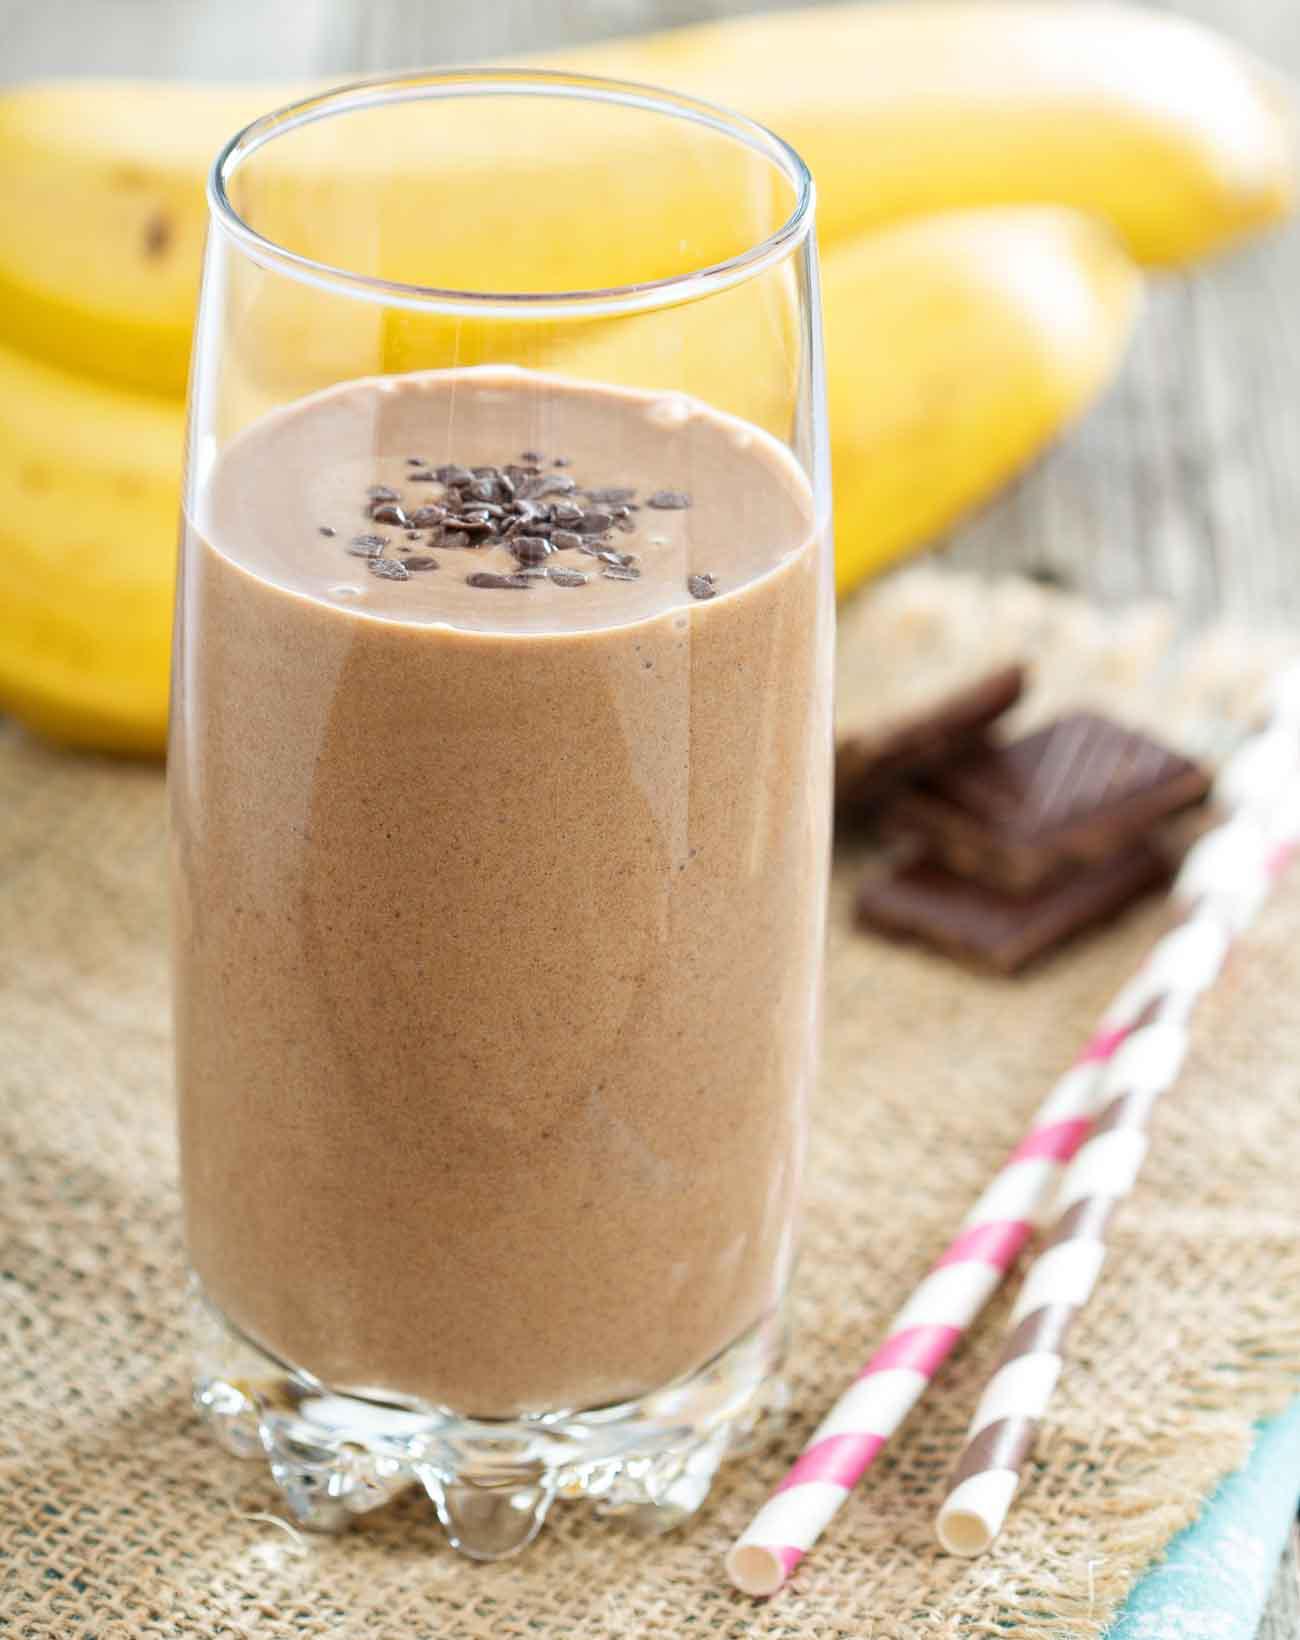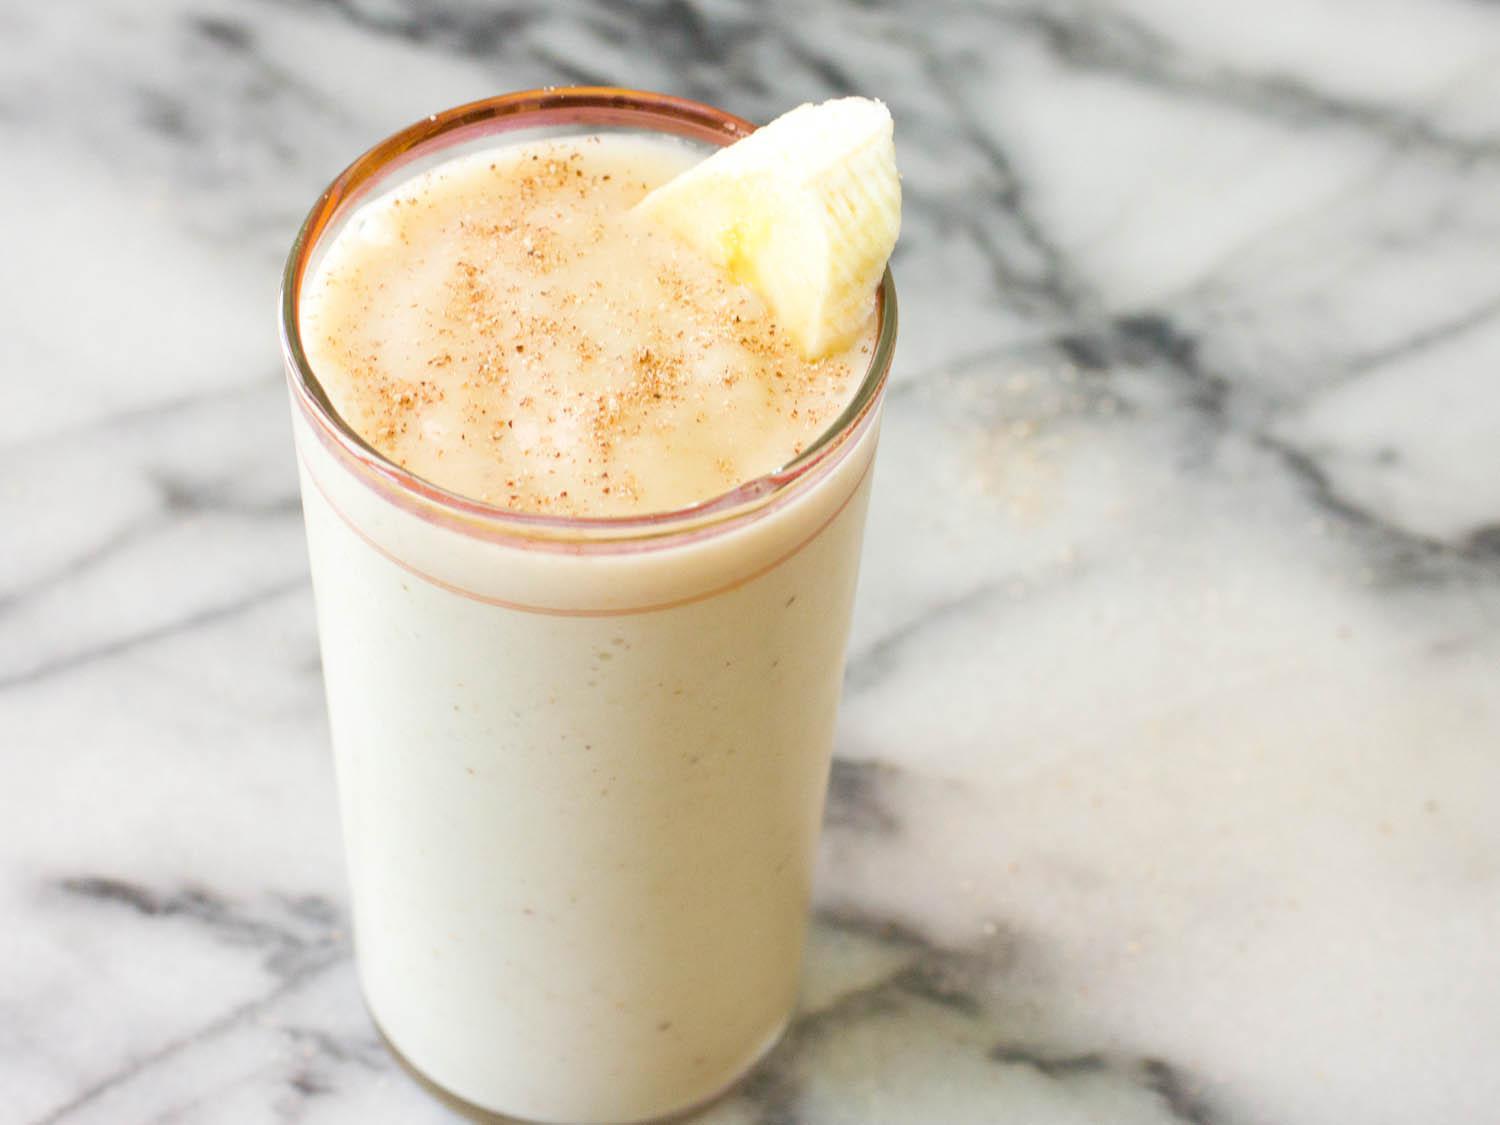The first image is the image on the left, the second image is the image on the right. Given the left and right images, does the statement "The image on the left shows two smoothie glasses next to at least one banana." hold true? Answer yes or no. No. The first image is the image on the left, the second image is the image on the right. Assess this claim about the two images: "The straws have stripes on them.". Correct or not? Answer yes or no. Yes. 